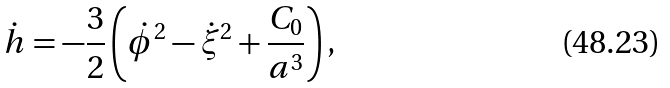Convert formula to latex. <formula><loc_0><loc_0><loc_500><loc_500>\dot { h } = - \frac { 3 } { 2 } \left ( \dot { \phi } ^ { 2 } - \dot { \xi } ^ { 2 } + \frac { C _ { 0 } } { a ^ { 3 } } \right ) ,</formula> 